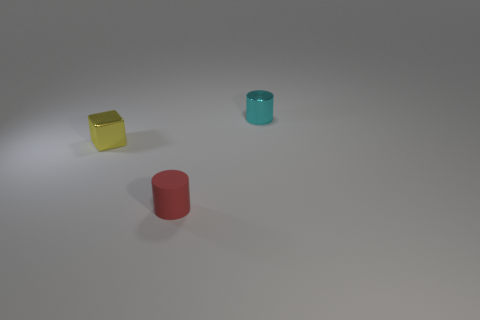There is a thing that is behind the small red cylinder and on the left side of the small shiny cylinder; what color is it? The object behind the small red cylinder and on the left side of the small shiny cylinder appears to be a yellow cube with a surface resembling matte or satin finish, softly lit by ambient light. 